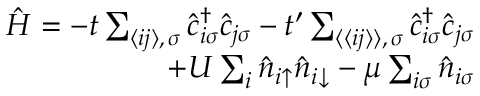Convert formula to latex. <formula><loc_0><loc_0><loc_500><loc_500>\begin{array} { r } { \hat { H } = - t \sum _ { \langle i j \rangle , \, \sigma } \hat { c } _ { i \sigma } ^ { \dagger } \hat { c } _ { j \sigma } - t ^ { \prime } \sum _ { \langle \langle i j \rangle \rangle , \, \sigma } \hat { c } _ { i \sigma } ^ { \dagger } \hat { c } _ { j \sigma } } \\ { + U \sum _ { i } \hat { n } _ { i \uparrow } \hat { n } _ { i \downarrow } - \mu \sum _ { i \sigma } \hat { n } _ { i \sigma } } \end{array}</formula> 